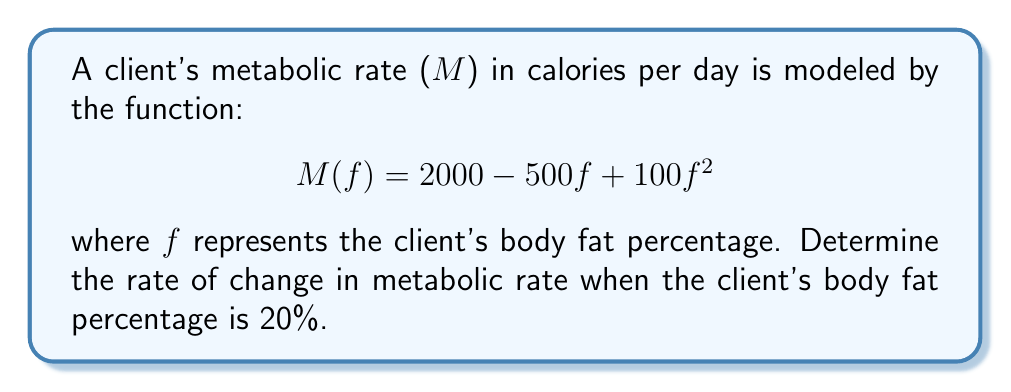Show me your answer to this math problem. To find the rate of change in metabolic rate as a function of body composition, we need to calculate the derivative of the given function M(f) with respect to f.

Step 1: Differentiate M(f) with respect to f.
$$\frac{dM}{df} = -500 + 200f$$

Step 2: Evaluate the derivative at f = 20% (0.20).
$$\frac{dM}{df}\bigg|_{f=0.20} = -500 + 200(0.20)$$
$$= -500 + 40$$
$$= -460$$

The negative value indicates that the metabolic rate is decreasing at this point.

Step 3: Interpret the result.
The rate of change in metabolic rate when the client's body fat percentage is 20% is -460 calories per day per percentage point of body fat.
Answer: -460 calories/day/% 